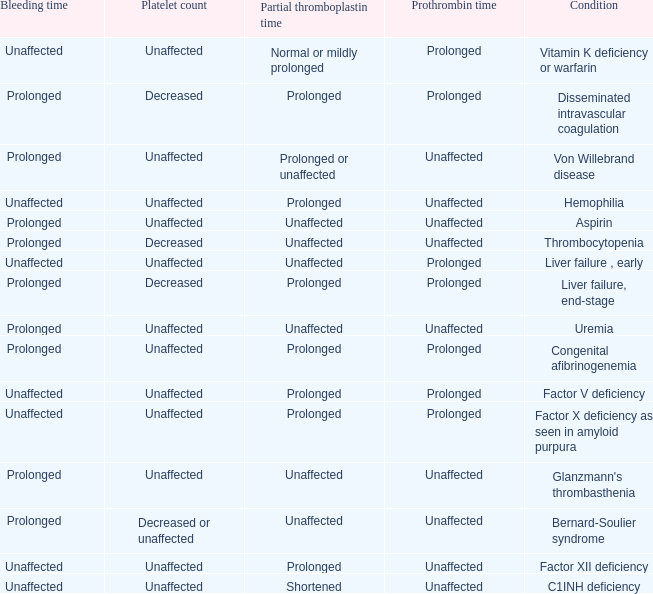Parse the full table. {'header': ['Bleeding time', 'Platelet count', 'Partial thromboplastin time', 'Prothrombin time', 'Condition'], 'rows': [['Unaffected', 'Unaffected', 'Normal or mildly prolonged', 'Prolonged', 'Vitamin K deficiency or warfarin'], ['Prolonged', 'Decreased', 'Prolonged', 'Prolonged', 'Disseminated intravascular coagulation'], ['Prolonged', 'Unaffected', 'Prolonged or unaffected', 'Unaffected', 'Von Willebrand disease'], ['Unaffected', 'Unaffected', 'Prolonged', 'Unaffected', 'Hemophilia'], ['Prolonged', 'Unaffected', 'Unaffected', 'Unaffected', 'Aspirin'], ['Prolonged', 'Decreased', 'Unaffected', 'Unaffected', 'Thrombocytopenia'], ['Unaffected', 'Unaffected', 'Unaffected', 'Prolonged', 'Liver failure , early'], ['Prolonged', 'Decreased', 'Prolonged', 'Prolonged', 'Liver failure, end-stage'], ['Prolonged', 'Unaffected', 'Unaffected', 'Unaffected', 'Uremia'], ['Prolonged', 'Unaffected', 'Prolonged', 'Prolonged', 'Congenital afibrinogenemia'], ['Unaffected', 'Unaffected', 'Prolonged', 'Prolonged', 'Factor V deficiency'], ['Unaffected', 'Unaffected', 'Prolonged', 'Prolonged', 'Factor X deficiency as seen in amyloid purpura'], ['Prolonged', 'Unaffected', 'Unaffected', 'Unaffected', "Glanzmann's thrombasthenia"], ['Prolonged', 'Decreased or unaffected', 'Unaffected', 'Unaffected', 'Bernard-Soulier syndrome'], ['Unaffected', 'Unaffected', 'Prolonged', 'Unaffected', 'Factor XII deficiency'], ['Unaffected', 'Unaffected', 'Shortened', 'Unaffected', 'C1INH deficiency']]} Which Condition has an unaffected Prothrombin time and a Bleeding time, and a Partial thromboplastin time of prolonged? Hemophilia, Factor XII deficiency. 